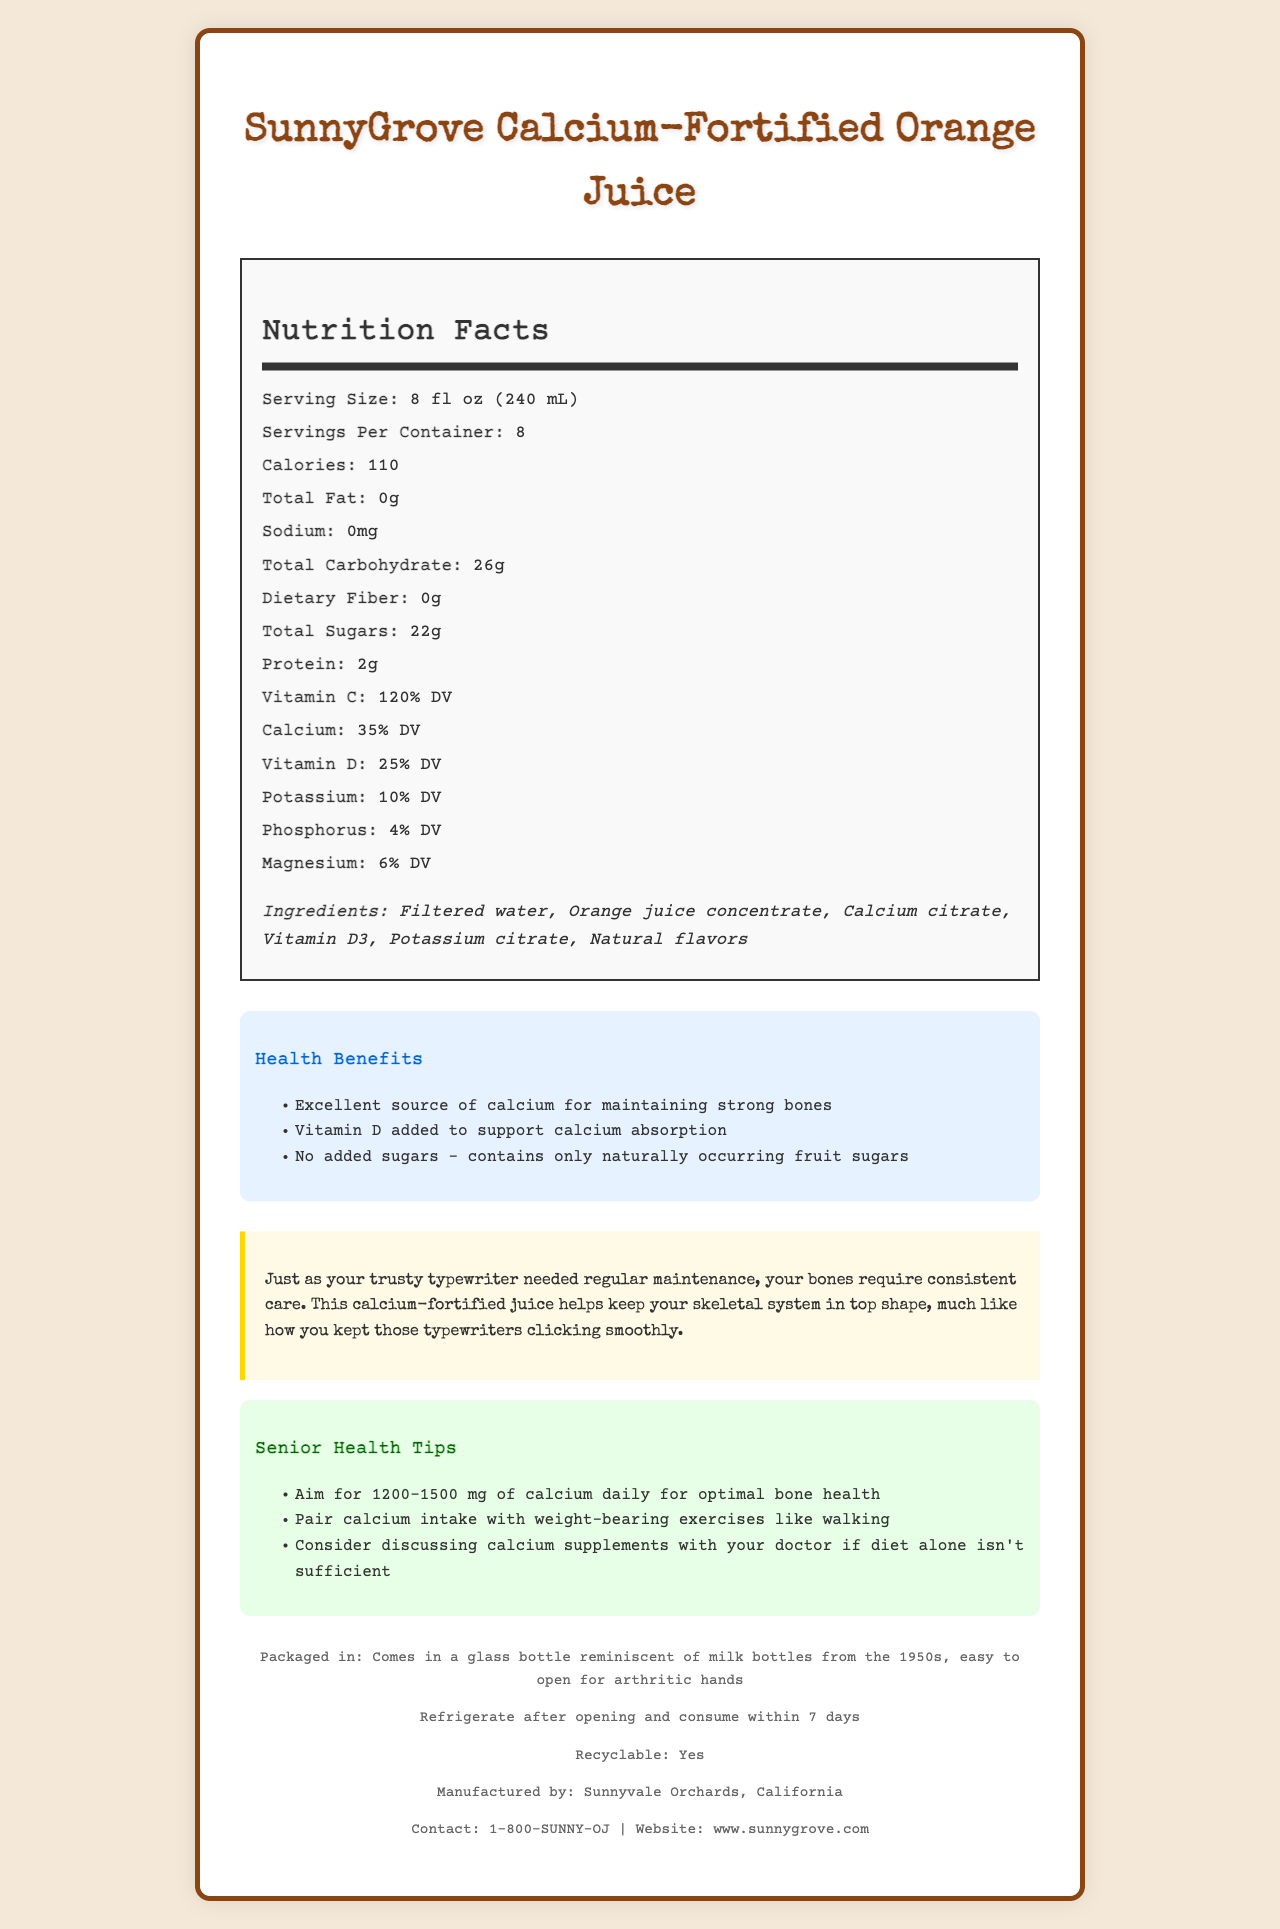who manufactures SunnyGrove Calcium-Fortified Orange Juice? The document states that the juice is manufactured by Sunnyvale Orchards, California.
Answer: Sunnyvale Orchards, California what is the serving size of the orange juice? The serving size is clearly listed as 8 fl oz (240 mL) in the document.
Answer: 8 fl oz (240 mL) how many servings are in each container? It is explicitly mentioned in the document that there are 8 servings per container.
Answer: 8 how much calcium does each serving provide? The amount of calcium per serving is listed as 35% of the Daily Value (DV).
Answer: 35% DV what are the main ingredients in this orange juice? The document provides a detailed list of the main ingredients including filtered water, orange juice concentrate, calcium citrate, vitamin D3, potassium citrate, and natural flavors.
Answer: Filtered water, Orange juice concentrate, Calcium citrate, Vitamin D3, Potassium citrate, Natural flavors which nutrient is present at 120% DV? A. Magnesium B. Vitamin D C. Vitamin C D. Phosphorus The document indicates that vitamin C is present at 120% DV.
Answer: C how is the packaging related to the 1950s? A. The bottle is reminiscent of milk bottles from that era. B. The packaging uses 1950s fonts. C. The packaging has retro colors. D. The label design is similar to advertisements from that era. The packaging is mentioned to come in a glass bottle reminiscent of milk bottles from the 1950s.
Answer: A is this juice fortified with vitamin D? The label specifies that vitamin D is added to support calcium absorption.
Answer: Yes does the juice contain added sugars? The health claims clearly state that there are no added sugars and it only contains naturally occurring fruit sugars.
Answer: No summarize the health benefits of SunnyGrove Calcium-Fortified Orange Juice. The health benefits are centered around bone strength, with calcium and vitamin D being the primary nutrients highlighted. The juice also promotes the absence of added sugars, making it a healthier option overall.
Answer: SunnyGrove Calcium-Fortified Orange Juice provides substantial health benefits, especially for maintaining strong bones. It is an excellent source of calcium (35% DV) and vitamin D (25% DV), which are crucial for bone health. The juice also boasts a high amount of vitamin C (120% DV) and benefits from having no added sugars. Older adults are advised to consume this juice to support optimal bone health. how does the product connect to the typewriter era? The typewriter-era connection leverages the consistent maintenance required for typewriters to draw a parallel with the need for regular bone care.
Answer: It emphasizes the consistent care needed for both typewriters and bones, using the analogy of maintaining a typewriter to illustrate the importance of regular bone care. how many grams of protein are in each serving? The nutrition facts state that there are 2 grams of protein per serving.
Answer: 2g what is the recommended daily calcium intake for older adults according to the document? The senior health tips recommend aiming for 1200-1500 mg of calcium daily for optimal bone health.
Answer: 1200-1500 mg how much dietary fiber is present in the juice? The document notes that there is no dietary fiber present in the juice.
Answer: 0g how should the juice be stored after opening? Storage instructions specify that the juice should be refrigerated after opening and consumed within 7 days.
Answer: Refrigerate and consume within 7 days is the packaging of the product recyclable? The document specifies that the packaging is recyclable.
Answer: Yes what is the exact percentage of DV for phosphorus? The nutritional information lists phosphorus at 4% DV.
Answer: 4% DV who should consider discussing calcium supplements with their doctor? The senior health tips suggest that older adults who may not get enough calcium from their diet should consider discussing calcium supplements with their doctor.
Answer: Older adults who may not get sufficient calcium from their diet. how many calories does each serving of this orange juice contain? The nutrition facts indicate that one serving contains 110 calories.
Answer: 110 can you determine the expiration date of the juice from the document? The document does not provide any details about the expiration date of the juice.
Answer: Not enough information 